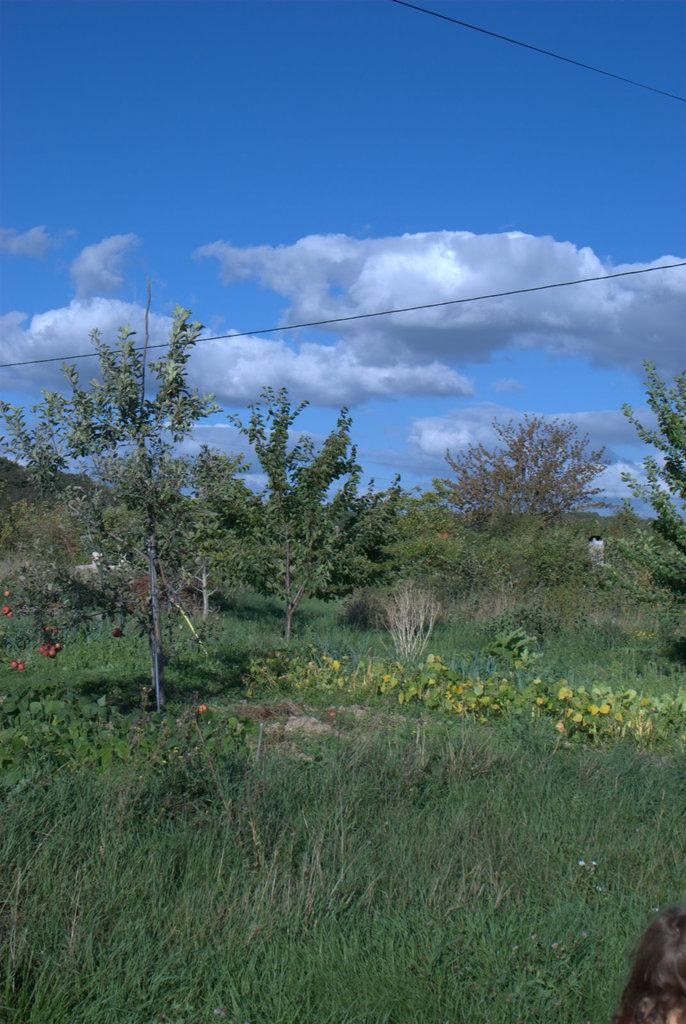What type of vegetation can be seen in the image? There is grass, plants, and trees visible in the image. What part of the natural environment is visible in the image? The sky is visible in the background of the image. Can you see a loaf of bread growing on the trees in the image? No, there is no loaf of bread present on the trees in the image. Are there any insects visible on the grass in the image? There is no mention of insects in the image, so it cannot be determined if any are present. 